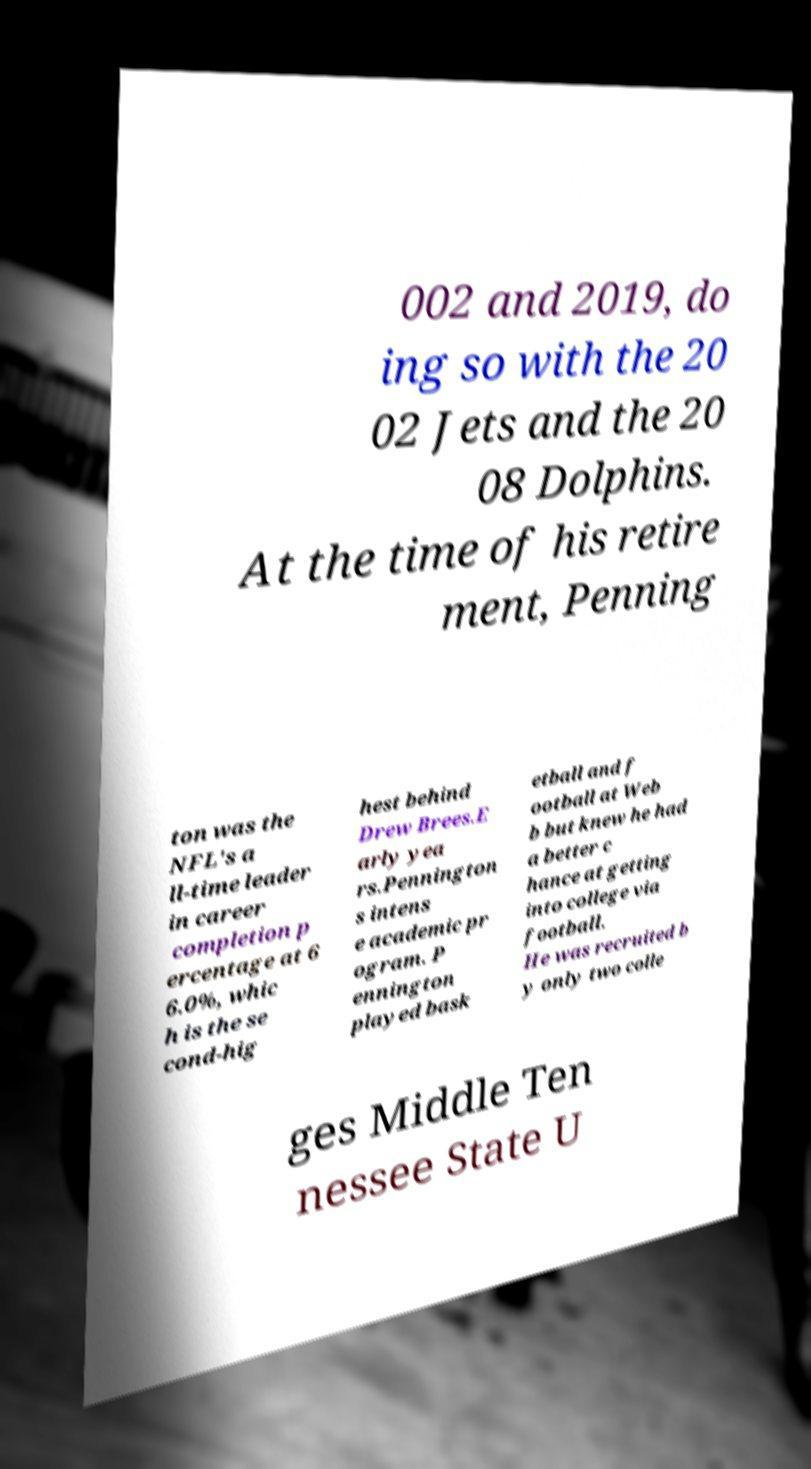Can you accurately transcribe the text from the provided image for me? 002 and 2019, do ing so with the 20 02 Jets and the 20 08 Dolphins. At the time of his retire ment, Penning ton was the NFL's a ll-time leader in career completion p ercentage at 6 6.0%, whic h is the se cond-hig hest behind Drew Brees.E arly yea rs.Pennington s intens e academic pr ogram. P ennington played bask etball and f ootball at Web b but knew he had a better c hance at getting into college via football. He was recruited b y only two colle ges Middle Ten nessee State U 